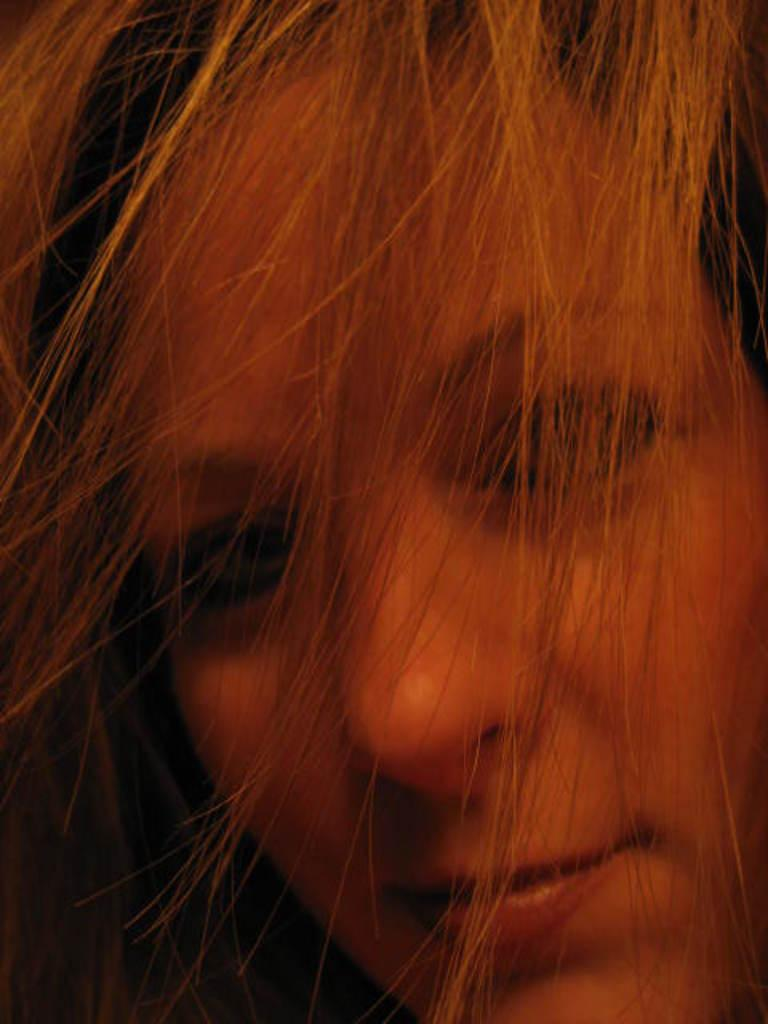What is the main subject of the image? The main subject of the image is the face of a person. What type of hair treatment is being applied to the person's hair in the image? There is no hair treatment visible in the image, as it only shows the face of a person. 